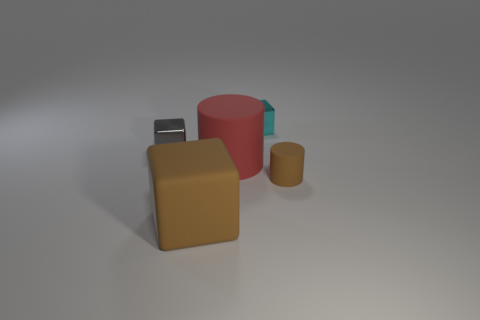Add 1 cyan cubes. How many objects exist? 6 Subtract all blocks. How many objects are left? 2 Add 4 tiny gray objects. How many tiny gray objects exist? 5 Subtract 0 purple cubes. How many objects are left? 5 Subtract all metallic cylinders. Subtract all tiny gray shiny things. How many objects are left? 4 Add 4 gray objects. How many gray objects are left? 5 